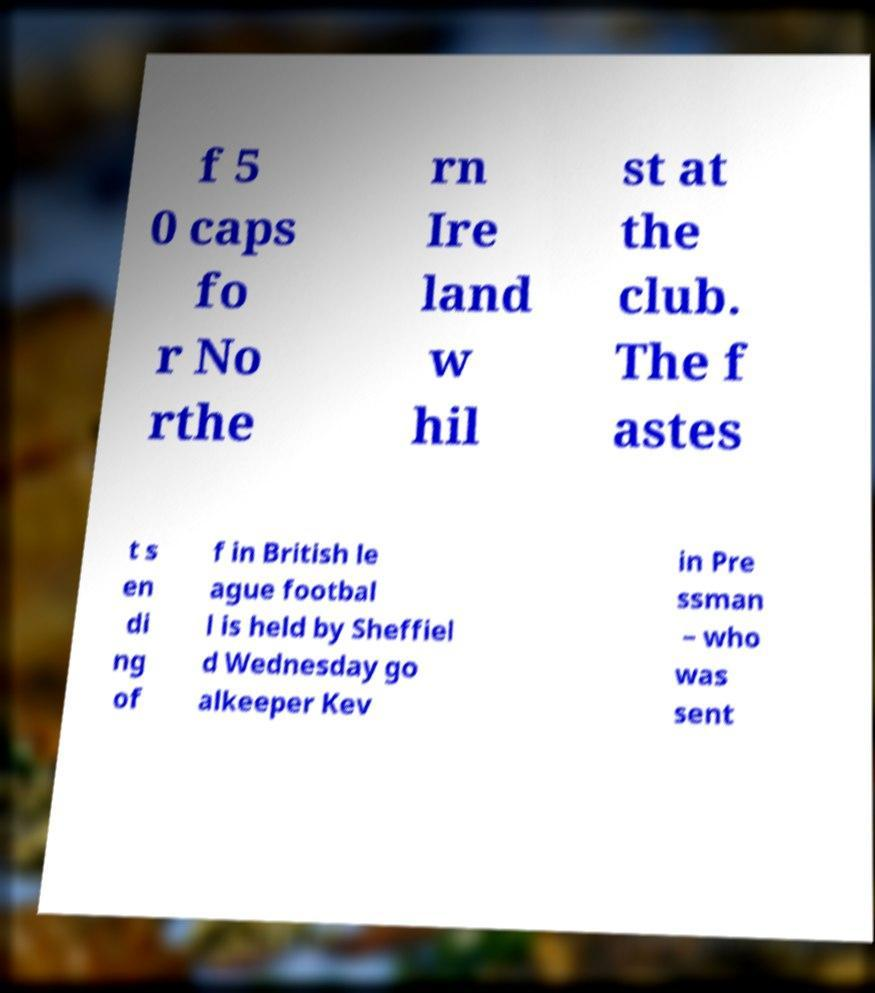Can you read and provide the text displayed in the image?This photo seems to have some interesting text. Can you extract and type it out for me? f 5 0 caps fo r No rthe rn Ire land w hil st at the club. The f astes t s en di ng of f in British le ague footbal l is held by Sheffiel d Wednesday go alkeeper Kev in Pre ssman – who was sent 